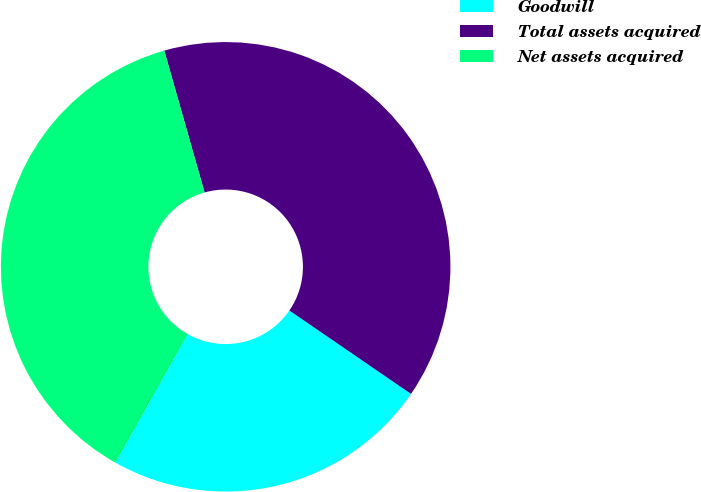Convert chart to OTSL. <chart><loc_0><loc_0><loc_500><loc_500><pie_chart><fcel>Goodwill<fcel>Total assets acquired<fcel>Net assets acquired<nl><fcel>23.58%<fcel>38.97%<fcel>37.45%<nl></chart> 